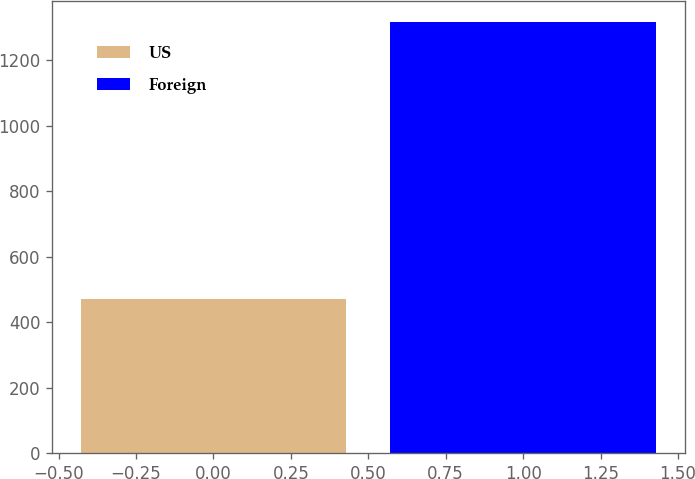Convert chart to OTSL. <chart><loc_0><loc_0><loc_500><loc_500><bar_chart><fcel>US<fcel>Foreign<nl><fcel>471<fcel>1316<nl></chart> 